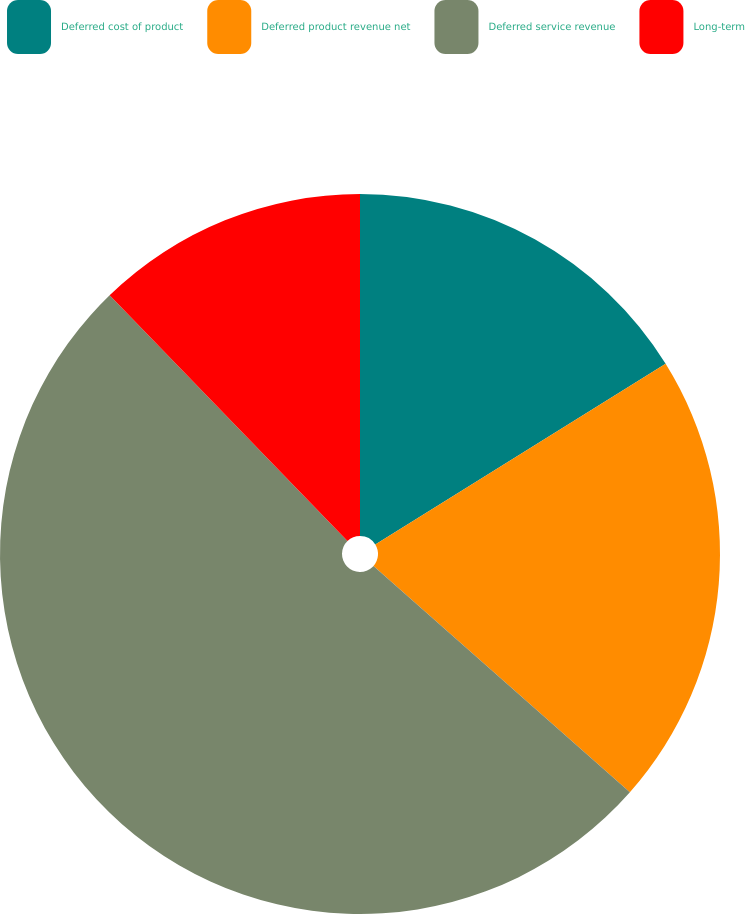<chart> <loc_0><loc_0><loc_500><loc_500><pie_chart><fcel>Deferred cost of product<fcel>Deferred product revenue net<fcel>Deferred service revenue<fcel>Long-term<nl><fcel>16.14%<fcel>20.37%<fcel>51.25%<fcel>12.24%<nl></chart> 